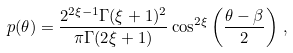<formula> <loc_0><loc_0><loc_500><loc_500>p ( \theta ) = \frac { 2 ^ { 2 \xi - 1 } \Gamma ( \xi + 1 ) ^ { 2 } } { \pi \Gamma ( 2 \xi + 1 ) } \cos ^ { 2 \xi } \left ( \frac { \theta - \beta } 2 \right ) \, ,</formula> 